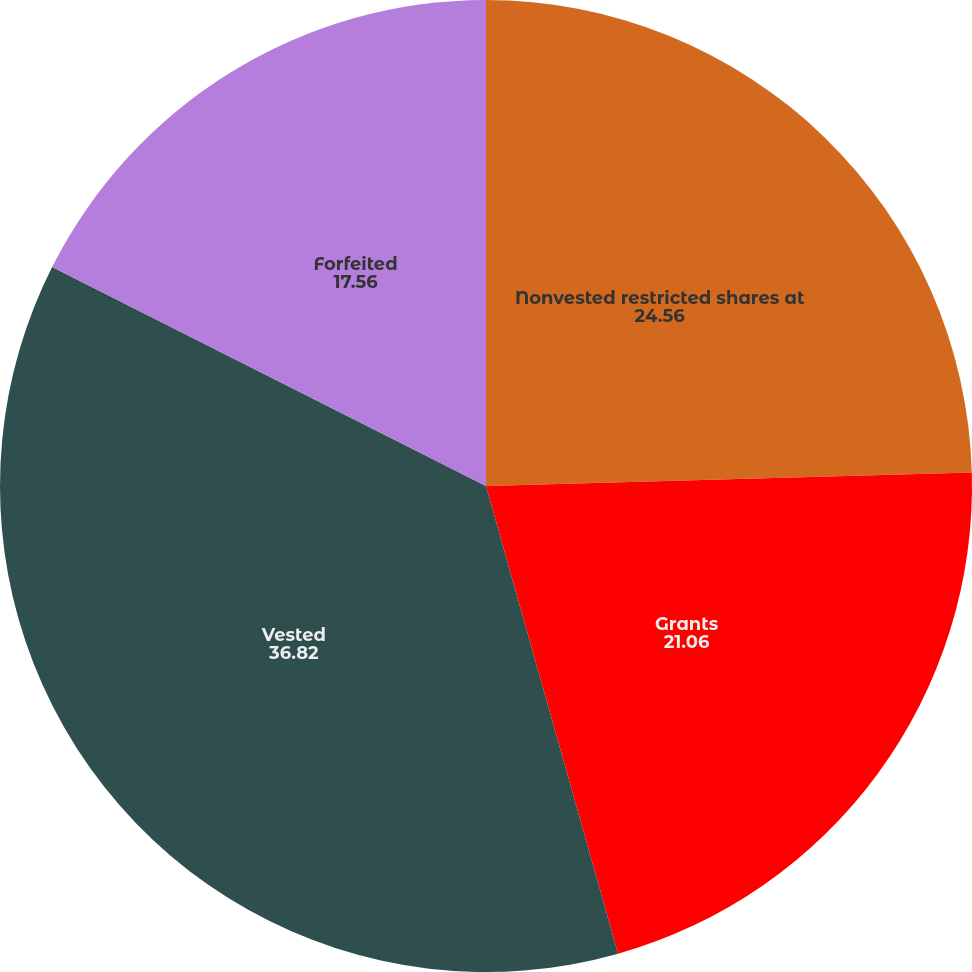Convert chart to OTSL. <chart><loc_0><loc_0><loc_500><loc_500><pie_chart><fcel>Nonvested restricted shares at<fcel>Grants<fcel>Vested<fcel>Forfeited<nl><fcel>24.56%<fcel>21.06%<fcel>36.82%<fcel>17.56%<nl></chart> 